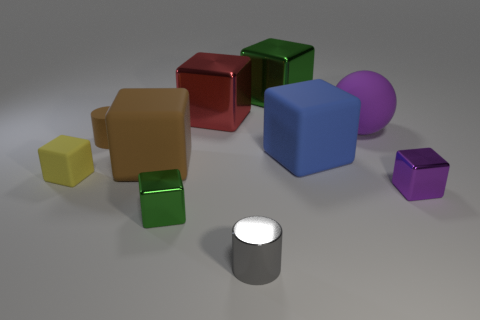There is a green metallic block that is on the left side of the tiny gray metal thing; what size is it?
Give a very brief answer. Small. Is the number of purple shiny cubes that are to the left of the tiny gray cylinder less than the number of brown blocks behind the big matte ball?
Your response must be concise. No. What material is the cube that is behind the purple rubber thing and right of the gray shiny cylinder?
Your answer should be very brief. Metal. There is a green metallic object that is to the right of the shiny cylinder to the left of the blue block; what shape is it?
Keep it short and to the point. Cube. Do the big matte ball and the tiny rubber cube have the same color?
Your answer should be very brief. No. What number of green things are large matte things or tiny metallic cylinders?
Give a very brief answer. 0. There is a large blue matte thing; are there any matte things to the left of it?
Offer a terse response. Yes. The red thing has what size?
Provide a short and direct response. Large. There is a brown matte object that is the same shape as the small yellow rubber object; what is its size?
Ensure brevity in your answer.  Large. There is a cylinder that is behind the tiny purple thing; what number of big purple rubber things are behind it?
Give a very brief answer. 1. 